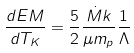Convert formula to latex. <formula><loc_0><loc_0><loc_500><loc_500>\frac { d E M } { d T _ { K } } = \frac { 5 } { 2 } \frac { \dot { M } k } { \mu m _ { p } } \frac { 1 } { \Lambda }</formula> 